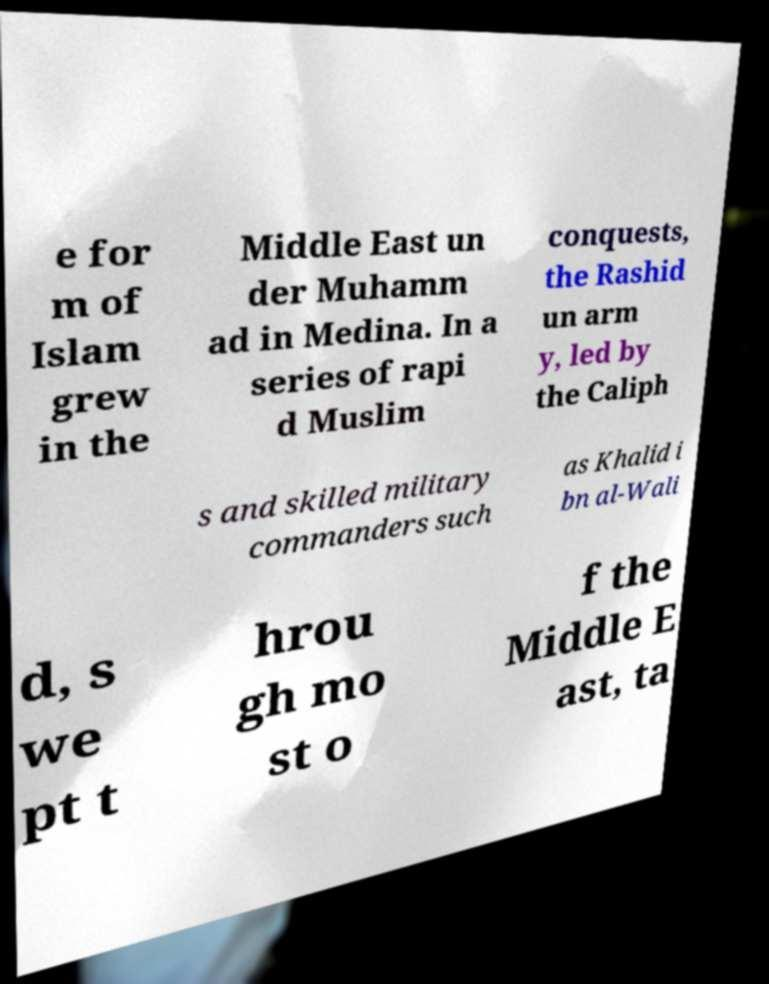Please identify and transcribe the text found in this image. e for m of Islam grew in the Middle East un der Muhamm ad in Medina. In a series of rapi d Muslim conquests, the Rashid un arm y, led by the Caliph s and skilled military commanders such as Khalid i bn al-Wali d, s we pt t hrou gh mo st o f the Middle E ast, ta 